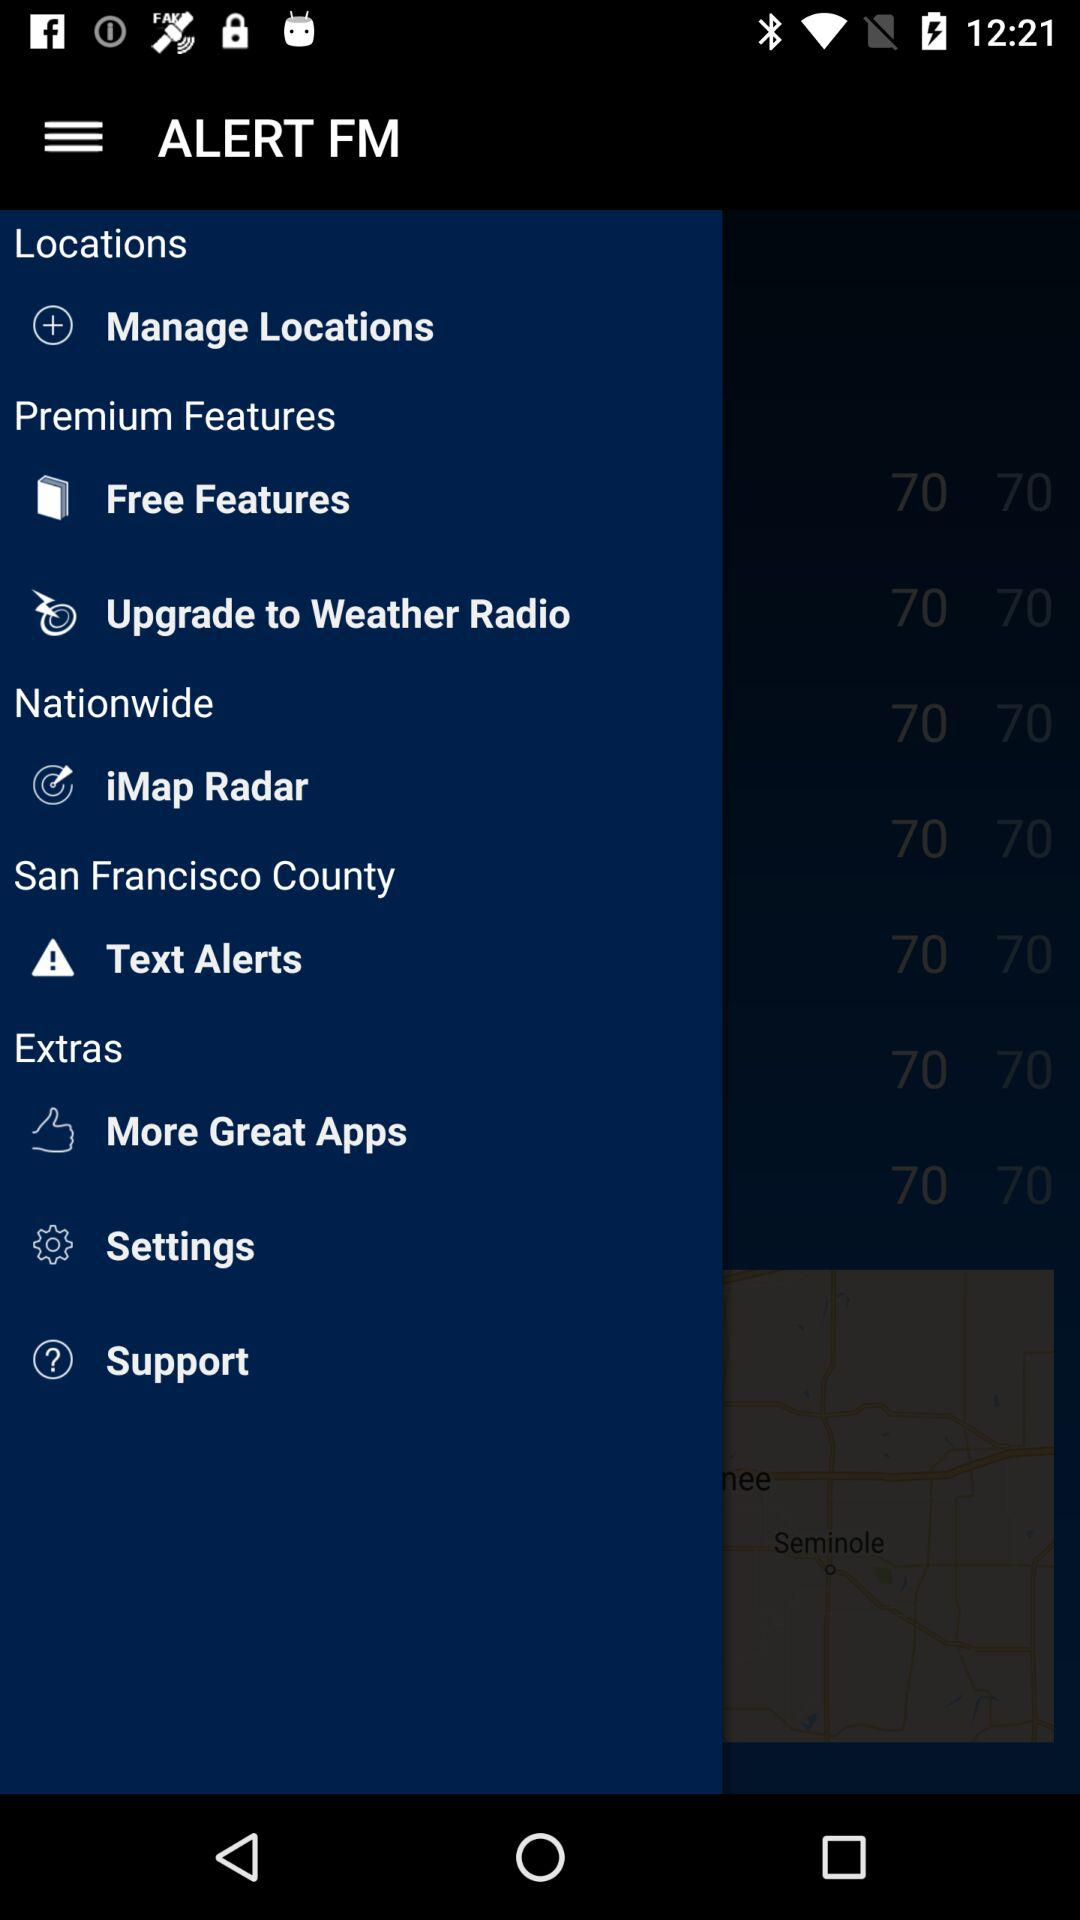What is the home ZIP code? The home ZIP code is 94101. 